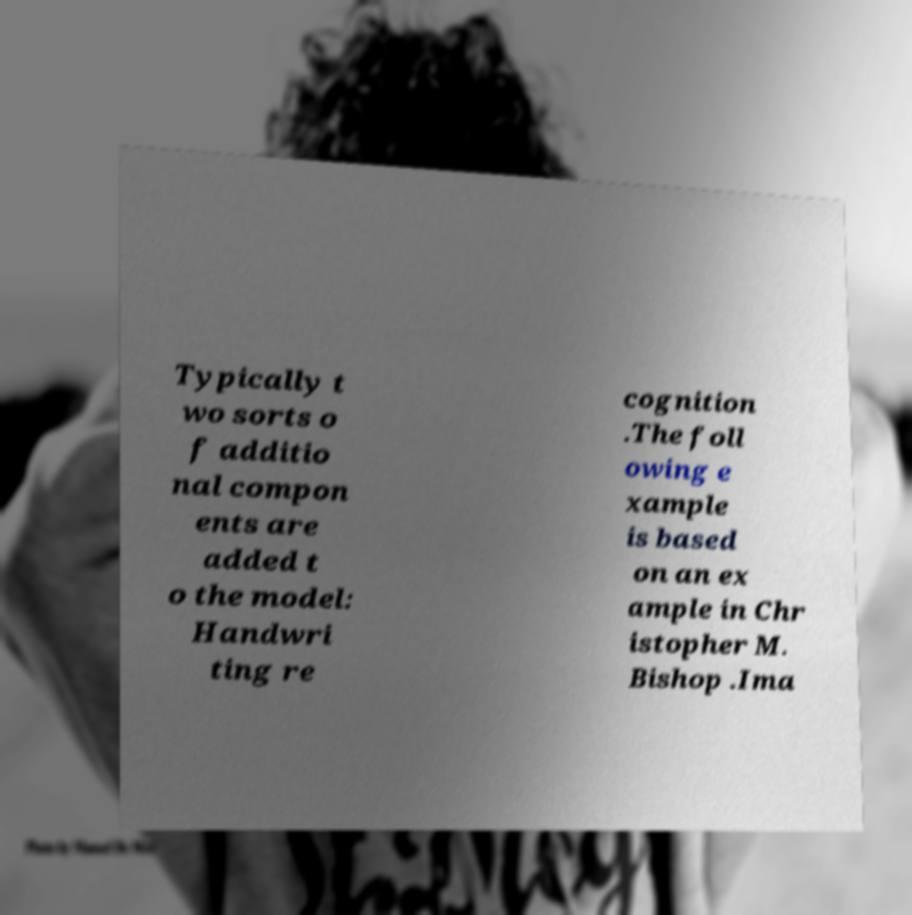Please identify and transcribe the text found in this image. Typically t wo sorts o f additio nal compon ents are added t o the model: Handwri ting re cognition .The foll owing e xample is based on an ex ample in Chr istopher M. Bishop .Ima 